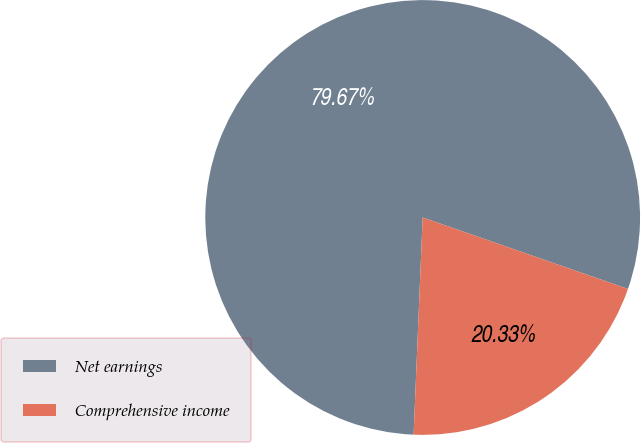<chart> <loc_0><loc_0><loc_500><loc_500><pie_chart><fcel>Net earnings<fcel>Comprehensive income<nl><fcel>79.67%<fcel>20.33%<nl></chart> 